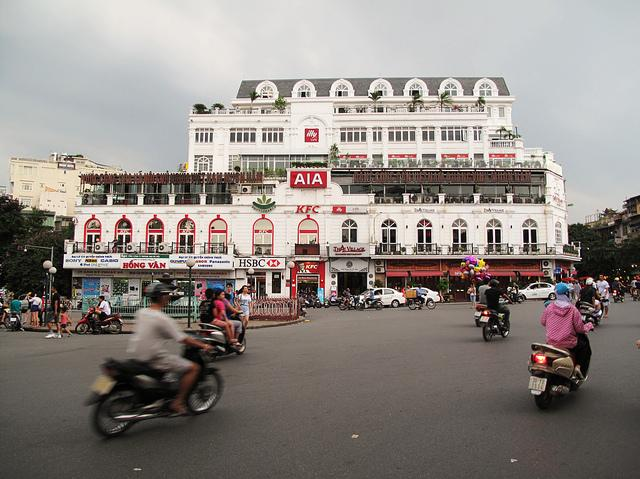What sort of bird meats are sold in this large building among other things? chicken 